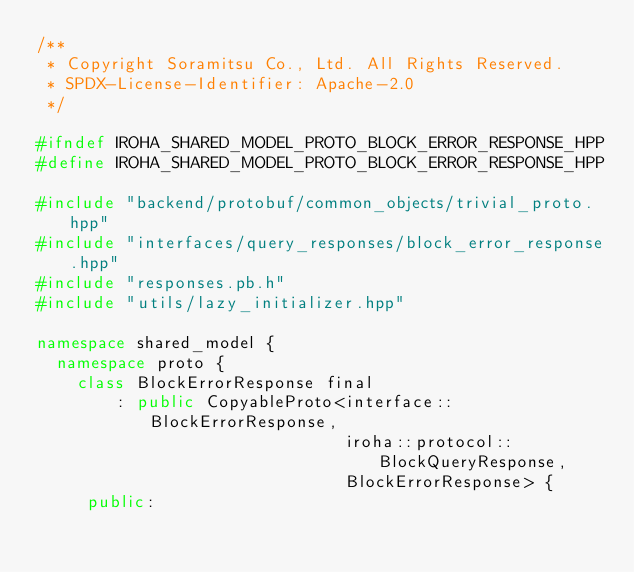<code> <loc_0><loc_0><loc_500><loc_500><_C++_>/**
 * Copyright Soramitsu Co., Ltd. All Rights Reserved.
 * SPDX-License-Identifier: Apache-2.0
 */

#ifndef IROHA_SHARED_MODEL_PROTO_BLOCK_ERROR_RESPONSE_HPP
#define IROHA_SHARED_MODEL_PROTO_BLOCK_ERROR_RESPONSE_HPP

#include "backend/protobuf/common_objects/trivial_proto.hpp"
#include "interfaces/query_responses/block_error_response.hpp"
#include "responses.pb.h"
#include "utils/lazy_initializer.hpp"

namespace shared_model {
  namespace proto {
    class BlockErrorResponse final
        : public CopyableProto<interface::BlockErrorResponse,
                               iroha::protocol::BlockQueryResponse,
                               BlockErrorResponse> {
     public:</code> 